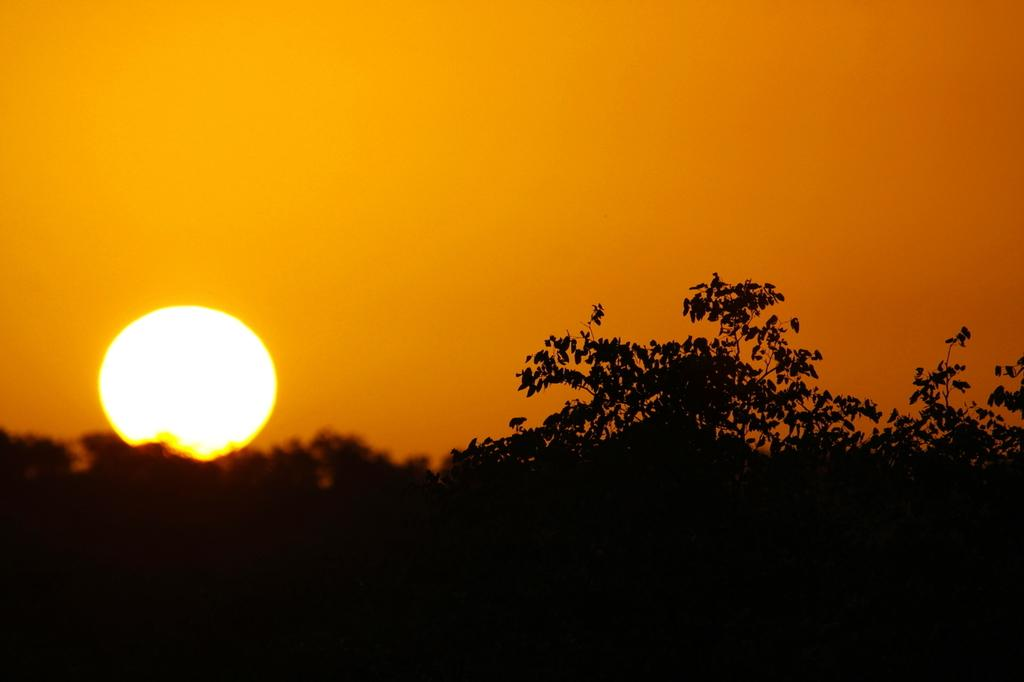What type of vegetation can be seen in the image? There are trees in the image. What celestial body is visible in the sky? The sun is visible in the sky. How does the fish feel about the trees in the image? There are no fish present in the image, so it is not possible to determine how a fish might feel about the trees. 